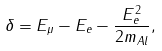Convert formula to latex. <formula><loc_0><loc_0><loc_500><loc_500>\delta = E _ { \mu } - E _ { e } - \frac { E _ { e } ^ { 2 } } { 2 m _ { A l } } ,</formula> 